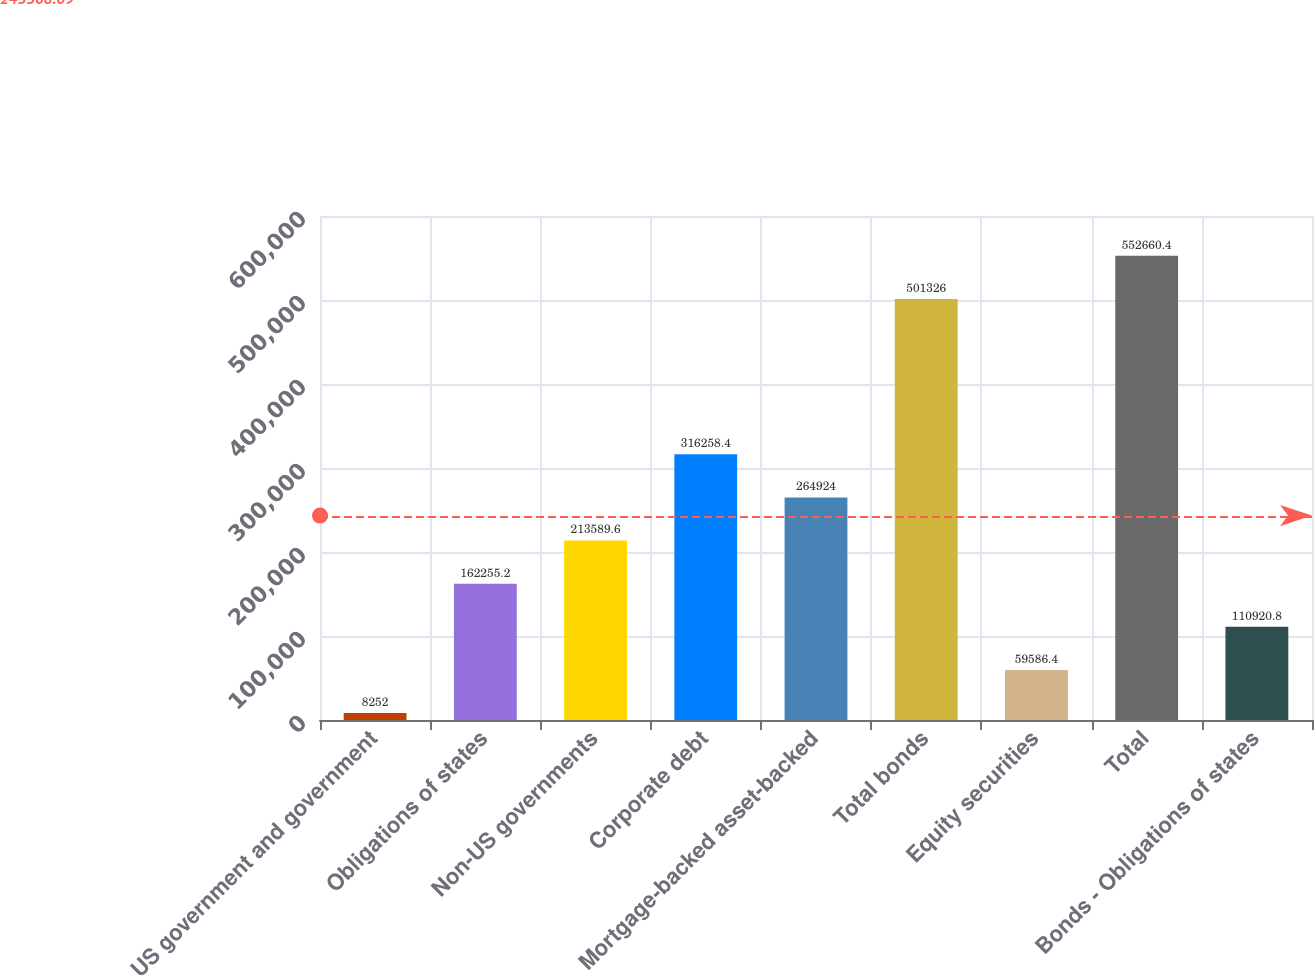Convert chart. <chart><loc_0><loc_0><loc_500><loc_500><bar_chart><fcel>US government and government<fcel>Obligations of states<fcel>Non-US governments<fcel>Corporate debt<fcel>Mortgage-backed asset-backed<fcel>Total bonds<fcel>Equity securities<fcel>Total<fcel>Bonds - Obligations of states<nl><fcel>8252<fcel>162255<fcel>213590<fcel>316258<fcel>264924<fcel>501326<fcel>59586.4<fcel>552660<fcel>110921<nl></chart> 